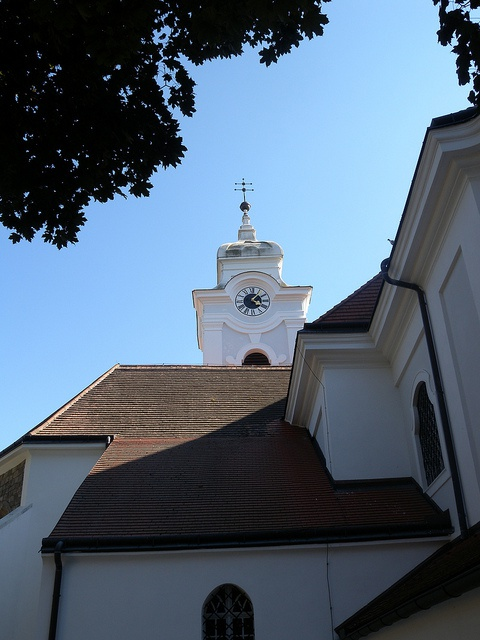Describe the objects in this image and their specific colors. I can see a clock in blue, gray, darkgray, and black tones in this image. 